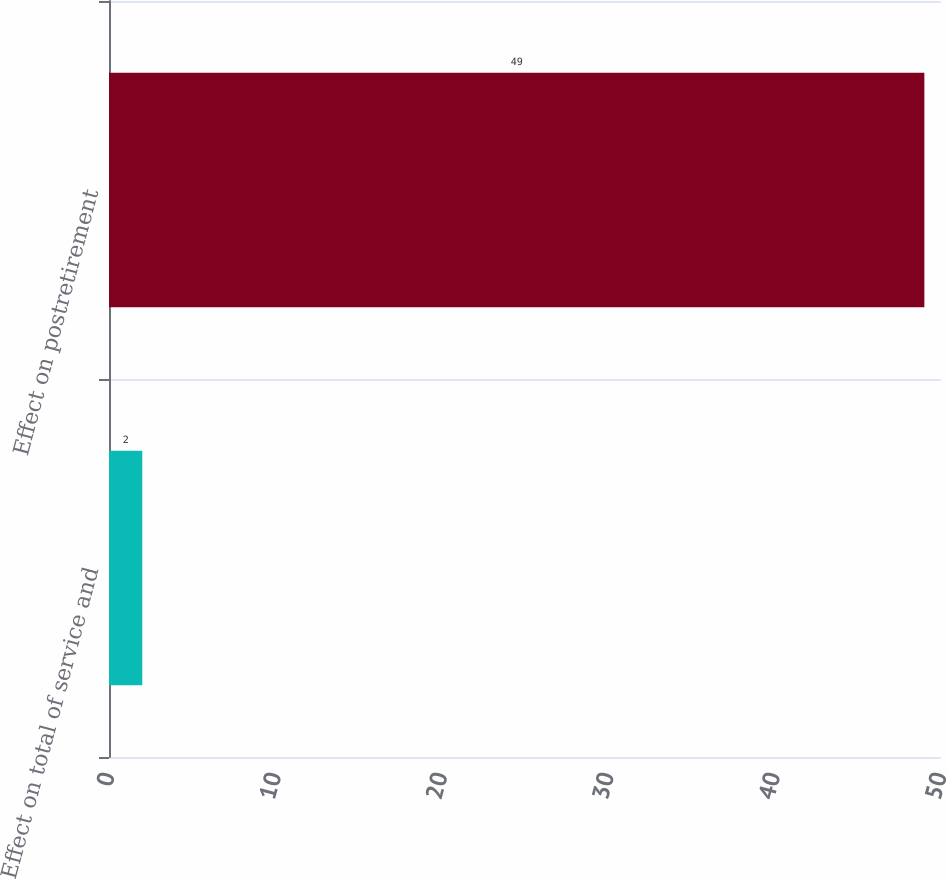Convert chart to OTSL. <chart><loc_0><loc_0><loc_500><loc_500><bar_chart><fcel>Effect on total of service and<fcel>Effect on postretirement<nl><fcel>2<fcel>49<nl></chart> 